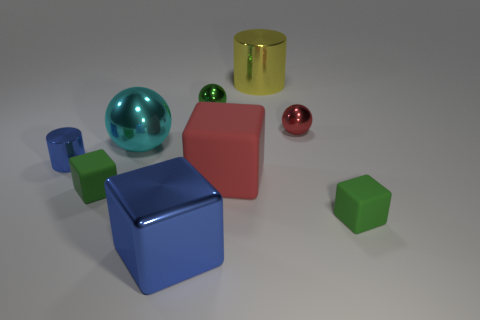Subtract 1 cubes. How many cubes are left? 3 Subtract all spheres. How many objects are left? 6 Add 5 red things. How many red things exist? 7 Subtract 0 gray spheres. How many objects are left? 9 Subtract all tiny metal objects. Subtract all big purple blocks. How many objects are left? 6 Add 6 big yellow metallic things. How many big yellow metallic things are left? 7 